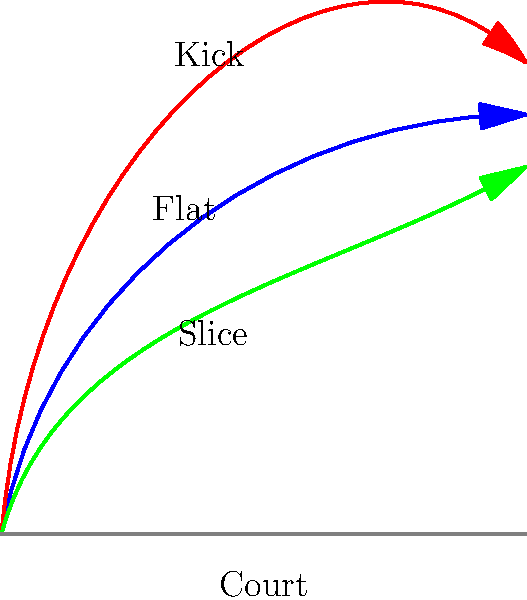As an amateur tennis player, you're working on improving your serve analysis skills. Based on the ball trajectory images shown, which serve type is represented by the blue line and why? To identify the serve type represented by the blue line, let's analyze the characteristics of each trajectory:

1. Blue line (top):
   - Starts with a steep angle
   - Maintains a relatively straight path
   - Ends with a horizontal direction

2. Red line (middle):
   - Starts with the steepest angle
   - Has a pronounced downward curve at the end
   - Finishes with a negative angle

3. Green line (bottom):
   - Starts with the shallowest angle
   - Has a slight upward curve
   - Ends with a positive angle

The blue line represents a flat serve because:
a) It has an initial steep angle, indicating a powerful serve
b) The trajectory remains relatively straight throughout its path
c) It finishes with a horizontal direction, suggesting minimal spin and maximum speed

Flat serves are known for their power and speed, with minimal spin. This allows the ball to travel quickly and maintain a straighter path compared to other serve types.

The red line likely represents a kick serve due to its steep initial angle and pronounced downward curve at the end, while the green line suggests a slice serve with its shallower angle and slight upward curve.
Answer: Flat serve 